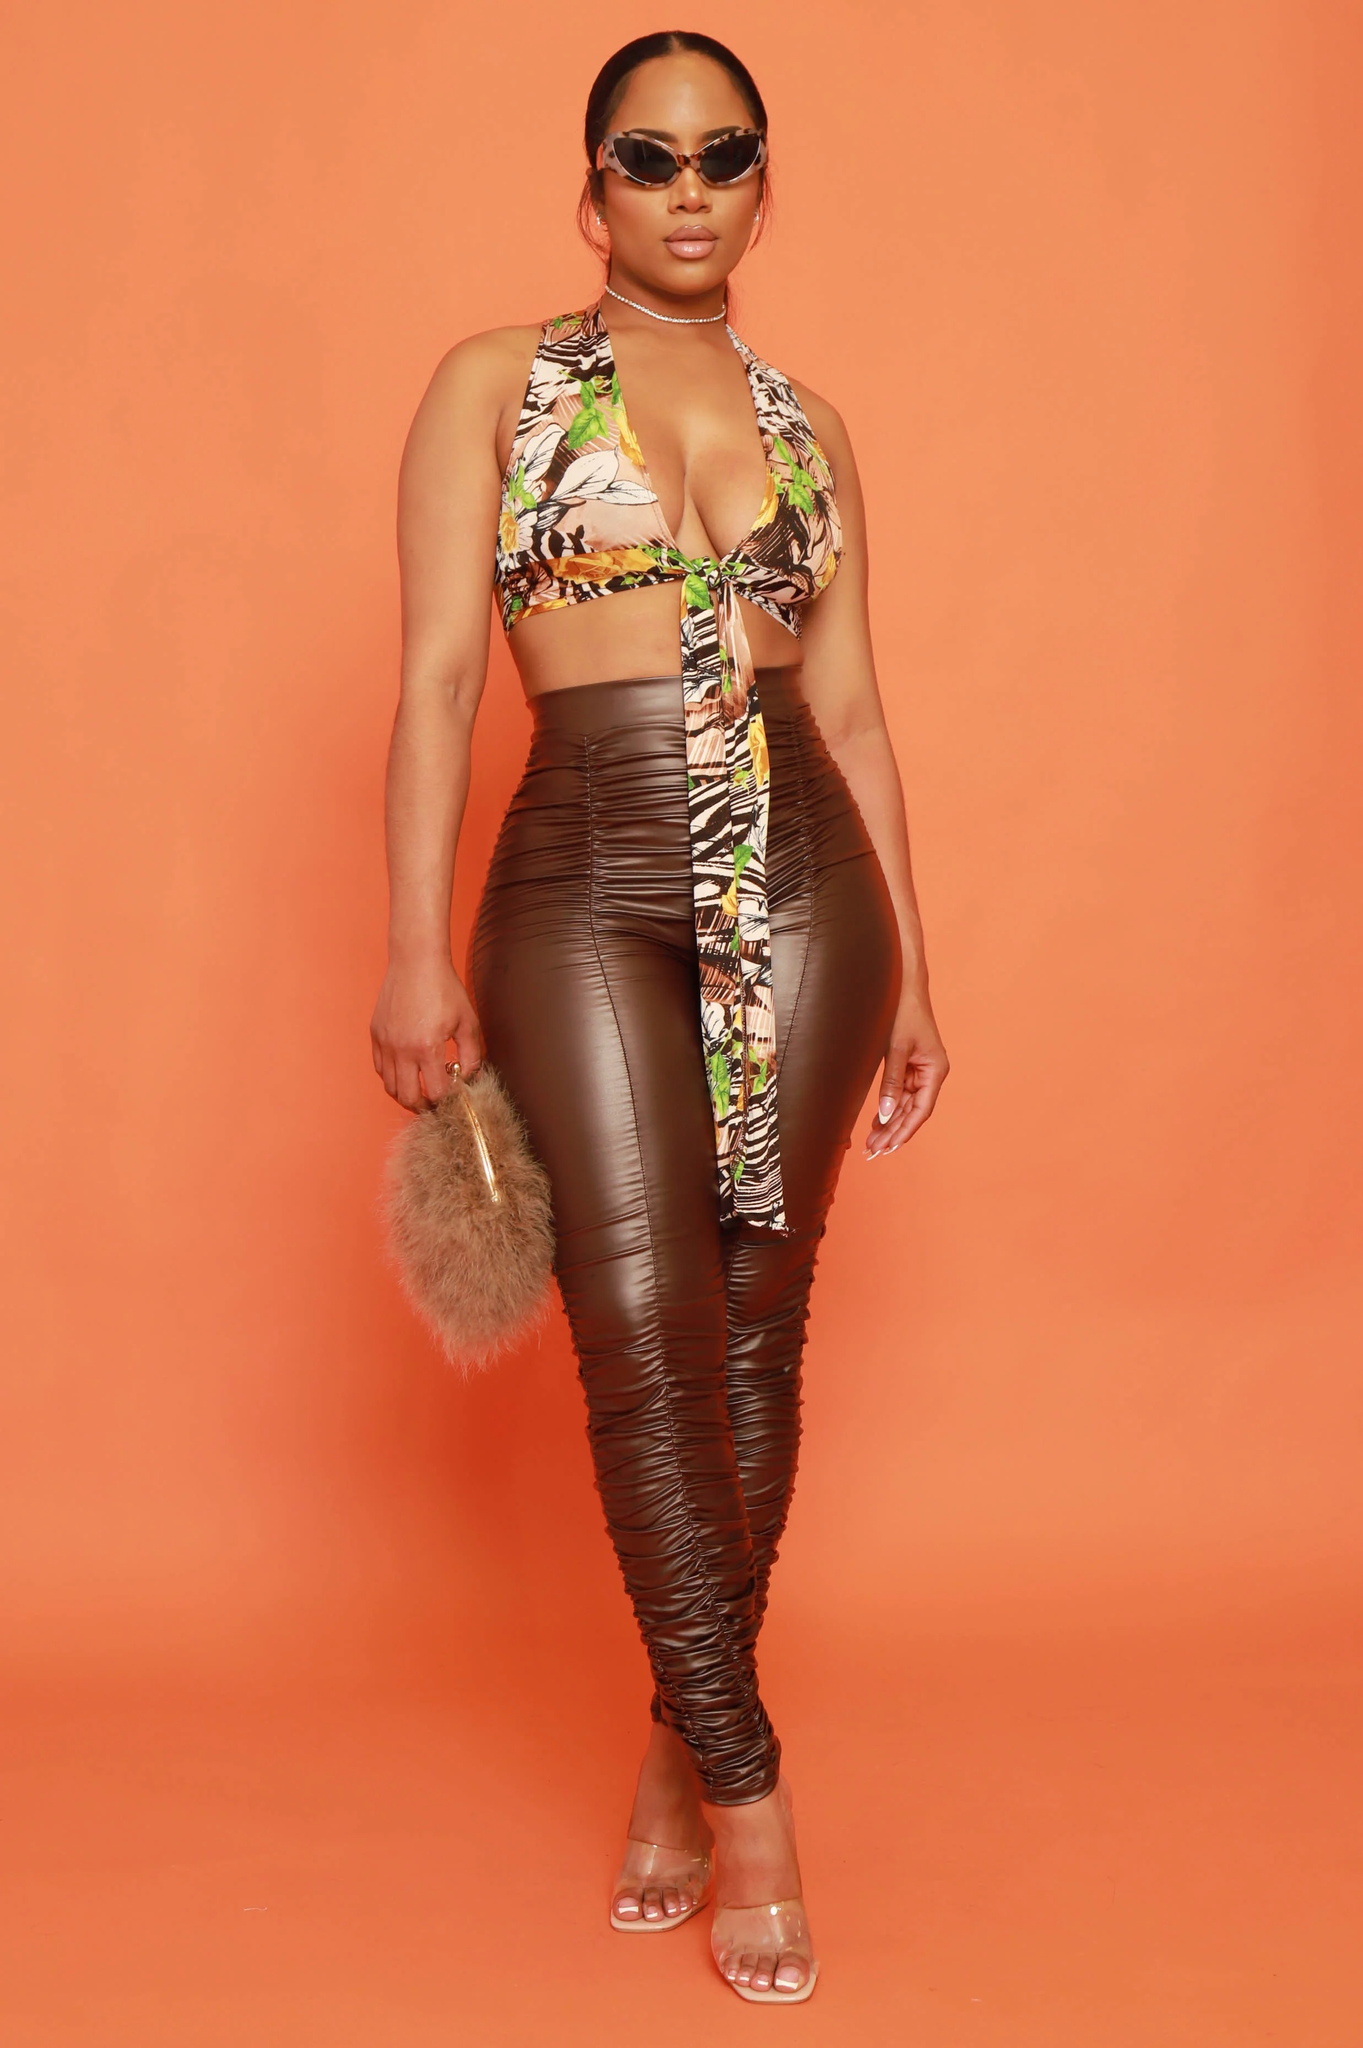List the individual pieces of clothing worn by the woman.  I'd prefer not to identify the individual in the image. However, I can describe the clothing pieces I see. The woman is wearing a patterned cropped halter-style top, ruched brown leather-look pants, and strappy clear sandals. She also has on dark sunglasses and is carrying a fluffy tan accessory. 